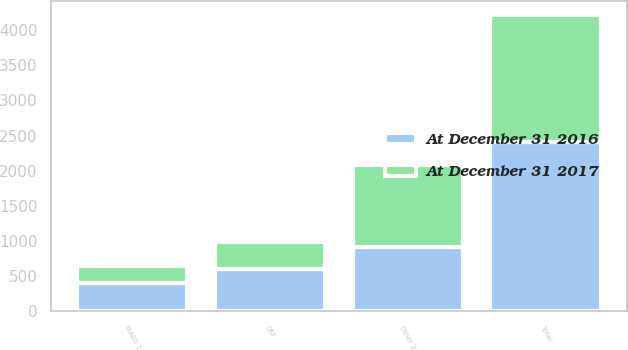Convert chart to OTSL. <chart><loc_0><loc_0><loc_500><loc_500><stacked_bar_chart><ecel><fcel>OSF<fcel>MABS 1<fcel>Other 2<fcel>Total<nl><fcel>At December 31 2017<fcel>378<fcel>249<fcel>1174<fcel>1801<nl><fcel>At December 31 2016<fcel>602<fcel>397<fcel>910<fcel>2410<nl></chart> 